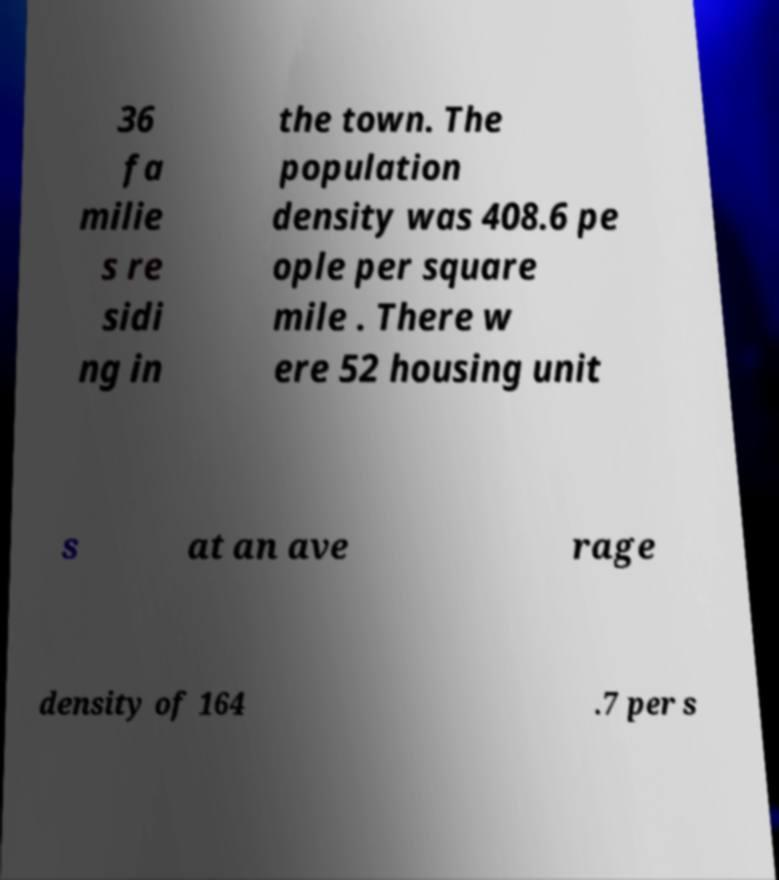Could you assist in decoding the text presented in this image and type it out clearly? 36 fa milie s re sidi ng in the town. The population density was 408.6 pe ople per square mile . There w ere 52 housing unit s at an ave rage density of 164 .7 per s 